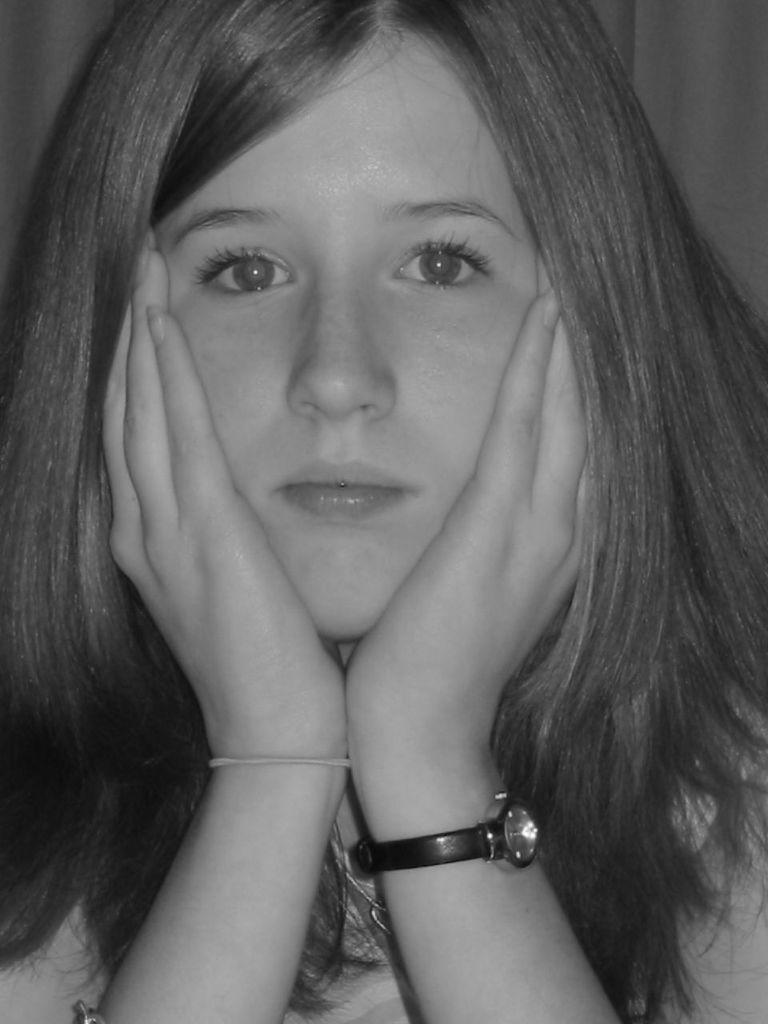Who is present in the image? There is a woman in the image. What is the woman wearing on her wrist? The woman is wearing a watch. What is the color scheme of the image? The image is in black and white. What type of butter is being spread on the pear by the coach in the image? There is no butter, pear, or coach present in the image. 